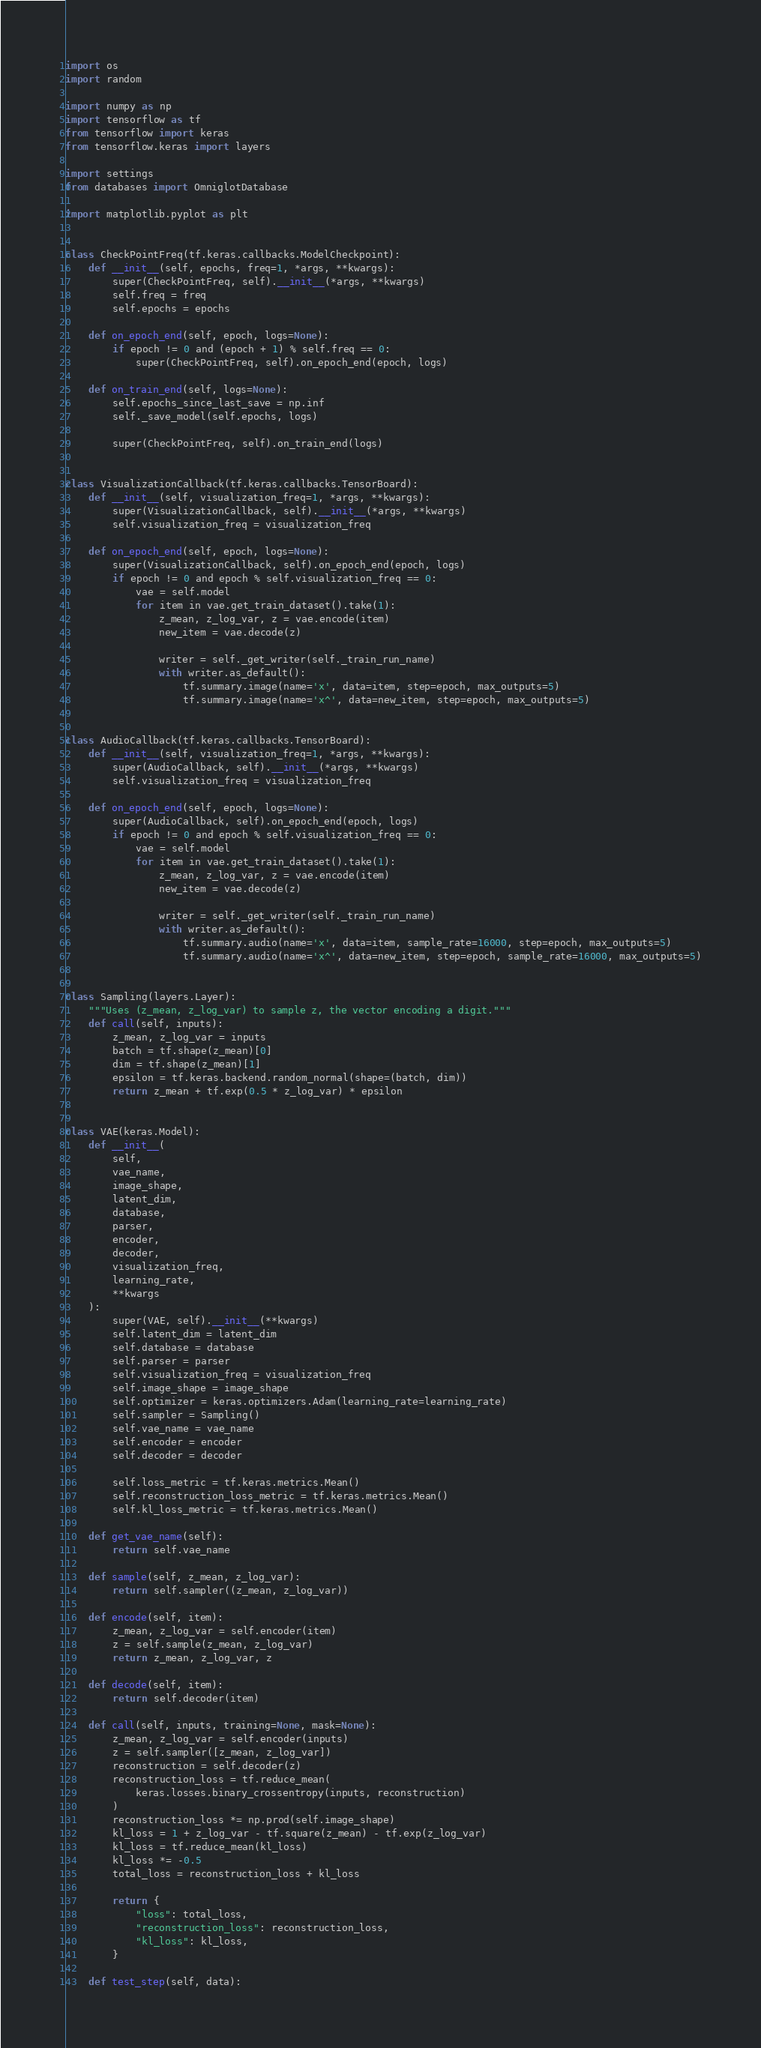<code> <loc_0><loc_0><loc_500><loc_500><_Python_>import os
import random

import numpy as np
import tensorflow as tf
from tensorflow import keras
from tensorflow.keras import layers

import settings
from databases import OmniglotDatabase

import matplotlib.pyplot as plt


class CheckPointFreq(tf.keras.callbacks.ModelCheckpoint):
    def __init__(self, epochs, freq=1, *args, **kwargs):
        super(CheckPointFreq, self).__init__(*args, **kwargs)
        self.freq = freq
        self.epochs = epochs

    def on_epoch_end(self, epoch, logs=None):
        if epoch != 0 and (epoch + 1) % self.freq == 0:
            super(CheckPointFreq, self).on_epoch_end(epoch, logs)

    def on_train_end(self, logs=None):
        self.epochs_since_last_save = np.inf
        self._save_model(self.epochs, logs)

        super(CheckPointFreq, self).on_train_end(logs)


class VisualizationCallback(tf.keras.callbacks.TensorBoard):
    def __init__(self, visualization_freq=1, *args, **kwargs):
        super(VisualizationCallback, self).__init__(*args, **kwargs)
        self.visualization_freq = visualization_freq

    def on_epoch_end(self, epoch, logs=None):
        super(VisualizationCallback, self).on_epoch_end(epoch, logs)
        if epoch != 0 and epoch % self.visualization_freq == 0:
            vae = self.model
            for item in vae.get_train_dataset().take(1):
                z_mean, z_log_var, z = vae.encode(item)
                new_item = vae.decode(z)

                writer = self._get_writer(self._train_run_name)
                with writer.as_default():
                    tf.summary.image(name='x', data=item, step=epoch, max_outputs=5)
                    tf.summary.image(name='x^', data=new_item, step=epoch, max_outputs=5)


class AudioCallback(tf.keras.callbacks.TensorBoard):
    def __init__(self, visualization_freq=1, *args, **kwargs):
        super(AudioCallback, self).__init__(*args, **kwargs)
        self.visualization_freq = visualization_freq

    def on_epoch_end(self, epoch, logs=None):
        super(AudioCallback, self).on_epoch_end(epoch, logs)
        if epoch != 0 and epoch % self.visualization_freq == 0:
            vae = self.model
            for item in vae.get_train_dataset().take(1):
                z_mean, z_log_var, z = vae.encode(item)
                new_item = vae.decode(z)

                writer = self._get_writer(self._train_run_name)
                with writer.as_default():
                    tf.summary.audio(name='x', data=item, sample_rate=16000, step=epoch, max_outputs=5)
                    tf.summary.audio(name='x^', data=new_item, step=epoch, sample_rate=16000, max_outputs=5)


class Sampling(layers.Layer):
    """Uses (z_mean, z_log_var) to sample z, the vector encoding a digit."""
    def call(self, inputs):
        z_mean, z_log_var = inputs
        batch = tf.shape(z_mean)[0]
        dim = tf.shape(z_mean)[1]
        epsilon = tf.keras.backend.random_normal(shape=(batch, dim))
        return z_mean + tf.exp(0.5 * z_log_var) * epsilon


class VAE(keras.Model):
    def __init__(
        self,
        vae_name,
        image_shape,
        latent_dim,
        database,
        parser,
        encoder,
        decoder,
        visualization_freq,
        learning_rate,
        **kwargs
    ):
        super(VAE, self).__init__(**kwargs)
        self.latent_dim = latent_dim
        self.database = database
        self.parser = parser
        self.visualization_freq = visualization_freq
        self.image_shape = image_shape
        self.optimizer = keras.optimizers.Adam(learning_rate=learning_rate)
        self.sampler = Sampling()
        self.vae_name = vae_name
        self.encoder = encoder
        self.decoder = decoder

        self.loss_metric = tf.keras.metrics.Mean()
        self.reconstruction_loss_metric = tf.keras.metrics.Mean()
        self.kl_loss_metric = tf.keras.metrics.Mean()

    def get_vae_name(self):
        return self.vae_name

    def sample(self, z_mean, z_log_var):
        return self.sampler((z_mean, z_log_var))

    def encode(self, item):
        z_mean, z_log_var = self.encoder(item)
        z = self.sample(z_mean, z_log_var)
        return z_mean, z_log_var, z

    def decode(self, item):
        return self.decoder(item)

    def call(self, inputs, training=None, mask=None):
        z_mean, z_log_var = self.encoder(inputs)
        z = self.sampler([z_mean, z_log_var])
        reconstruction = self.decoder(z)
        reconstruction_loss = tf.reduce_mean(
            keras.losses.binary_crossentropy(inputs, reconstruction)
        )
        reconstruction_loss *= np.prod(self.image_shape)
        kl_loss = 1 + z_log_var - tf.square(z_mean) - tf.exp(z_log_var)
        kl_loss = tf.reduce_mean(kl_loss)
        kl_loss *= -0.5
        total_loss = reconstruction_loss + kl_loss

        return {
            "loss": total_loss,
            "reconstruction_loss": reconstruction_loss,
            "kl_loss": kl_loss,
        }

    def test_step(self, data):</code> 